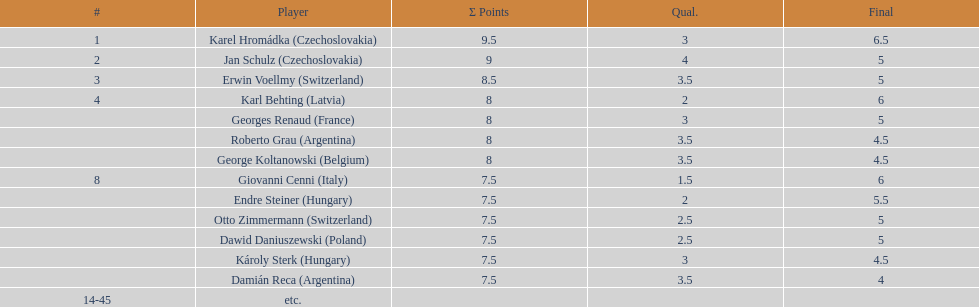Did the hungarian duo score higher or lower combined points than the argentine pair? Less. 